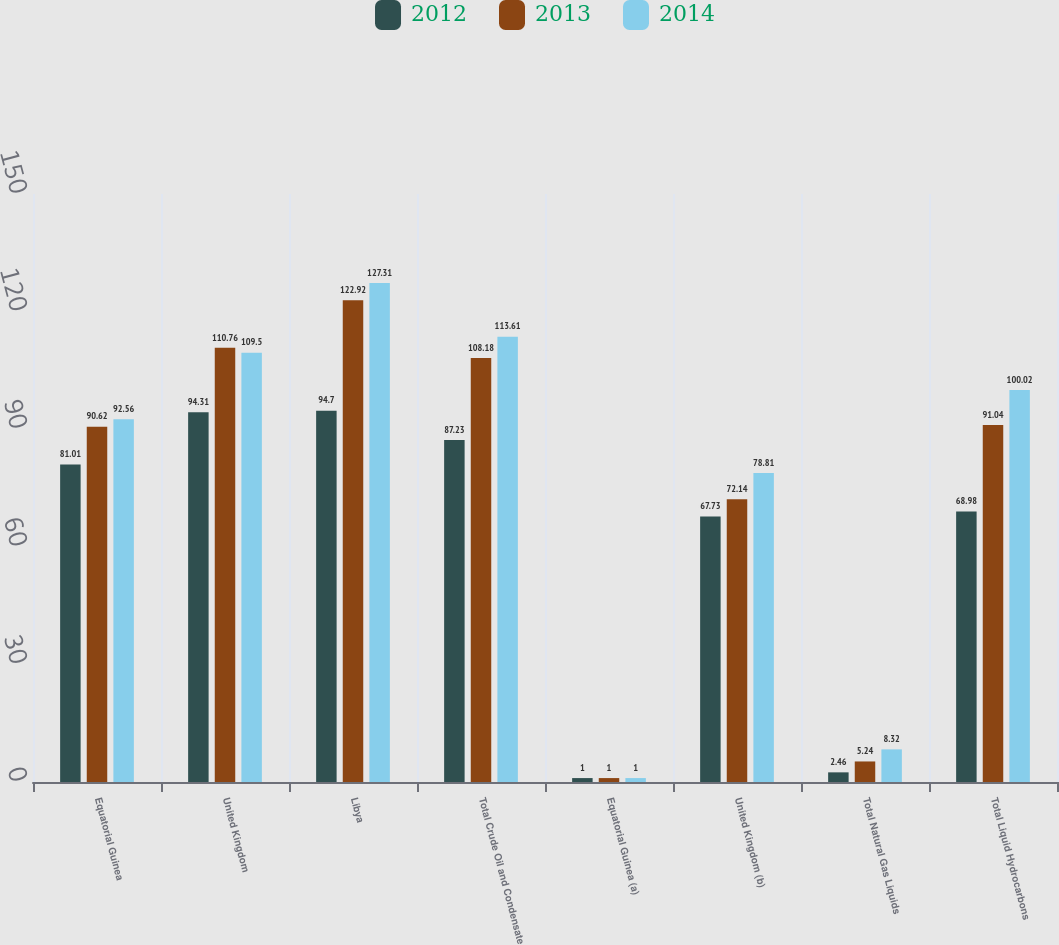Convert chart. <chart><loc_0><loc_0><loc_500><loc_500><stacked_bar_chart><ecel><fcel>Equatorial Guinea<fcel>United Kingdom<fcel>Libya<fcel>Total Crude Oil and Condensate<fcel>Equatorial Guinea (a)<fcel>United Kingdom (b)<fcel>Total Natural Gas Liquids<fcel>Total Liquid Hydrocarbons<nl><fcel>2012<fcel>81.01<fcel>94.31<fcel>94.7<fcel>87.23<fcel>1<fcel>67.73<fcel>2.46<fcel>68.98<nl><fcel>2013<fcel>90.62<fcel>110.76<fcel>122.92<fcel>108.18<fcel>1<fcel>72.14<fcel>5.24<fcel>91.04<nl><fcel>2014<fcel>92.56<fcel>109.5<fcel>127.31<fcel>113.61<fcel>1<fcel>78.81<fcel>8.32<fcel>100.02<nl></chart> 